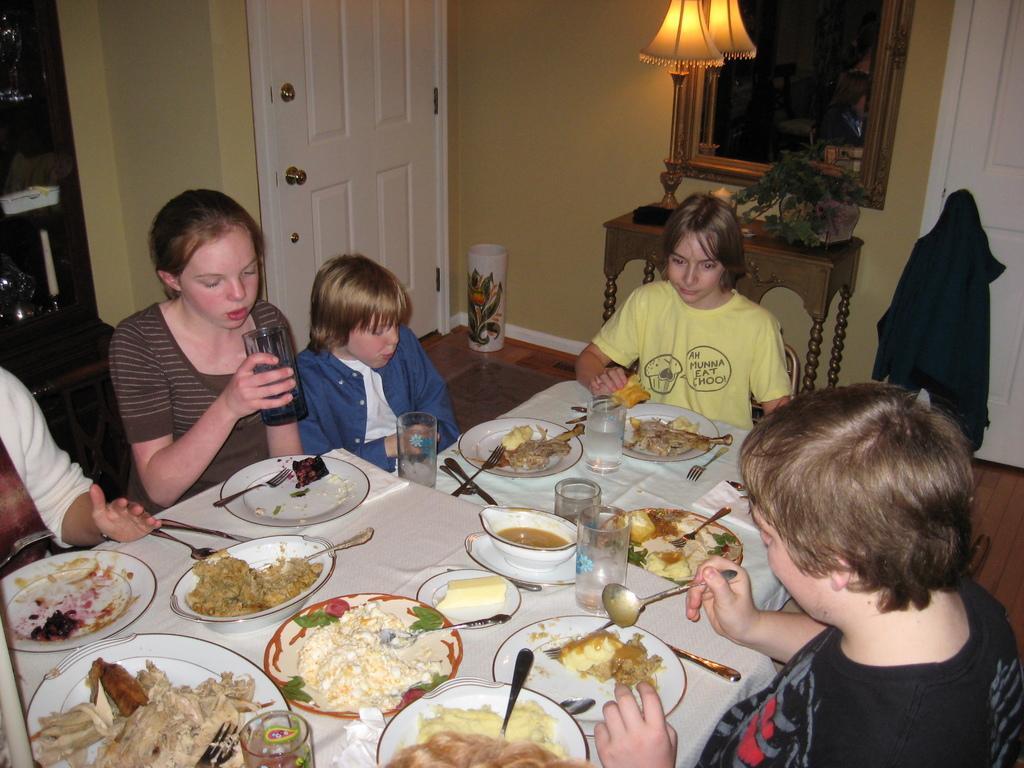How would you summarize this image in a sentence or two? In this image there are group of people sitting in chair near the table and in table there are spoon , knife , fork , food , cheese , plate , bowl , glass , and the back ground there is door , lamp , frame attached to wall. 